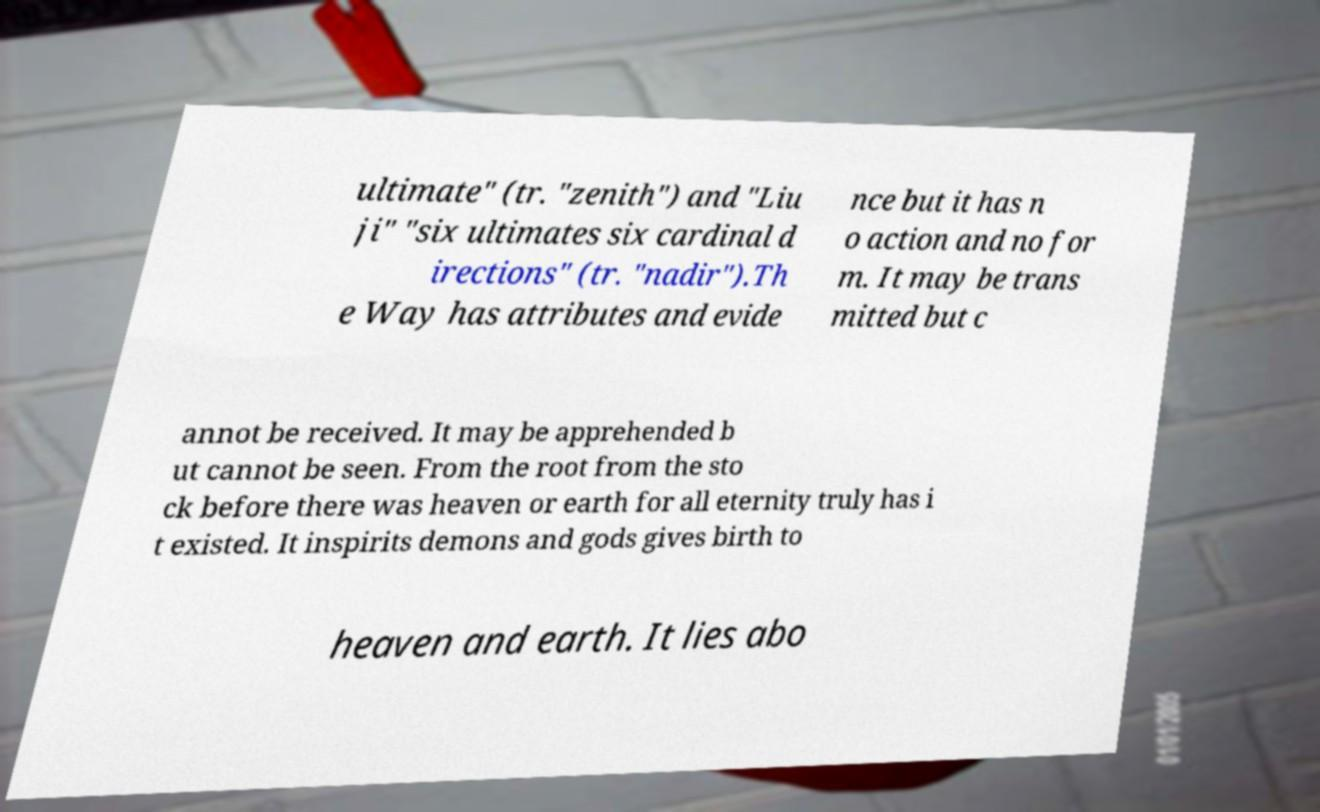Can you read and provide the text displayed in the image?This photo seems to have some interesting text. Can you extract and type it out for me? ultimate" (tr. "zenith") and "Liu ji" "six ultimates six cardinal d irections" (tr. "nadir").Th e Way has attributes and evide nce but it has n o action and no for m. It may be trans mitted but c annot be received. It may be apprehended b ut cannot be seen. From the root from the sto ck before there was heaven or earth for all eternity truly has i t existed. It inspirits demons and gods gives birth to heaven and earth. It lies abo 